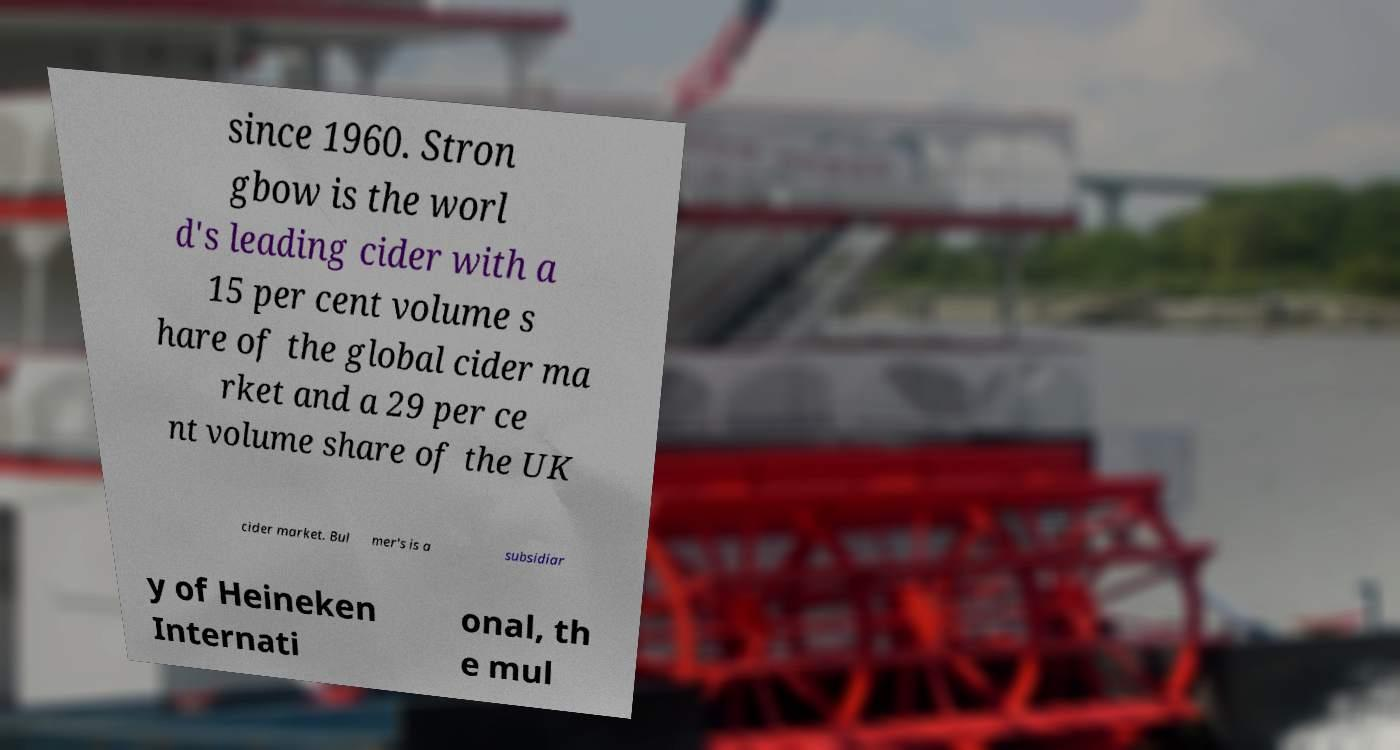Can you read and provide the text displayed in the image?This photo seems to have some interesting text. Can you extract and type it out for me? since 1960. Stron gbow is the worl d's leading cider with a 15 per cent volume s hare of the global cider ma rket and a 29 per ce nt volume share of the UK cider market. Bul mer's is a subsidiar y of Heineken Internati onal, th e mul 